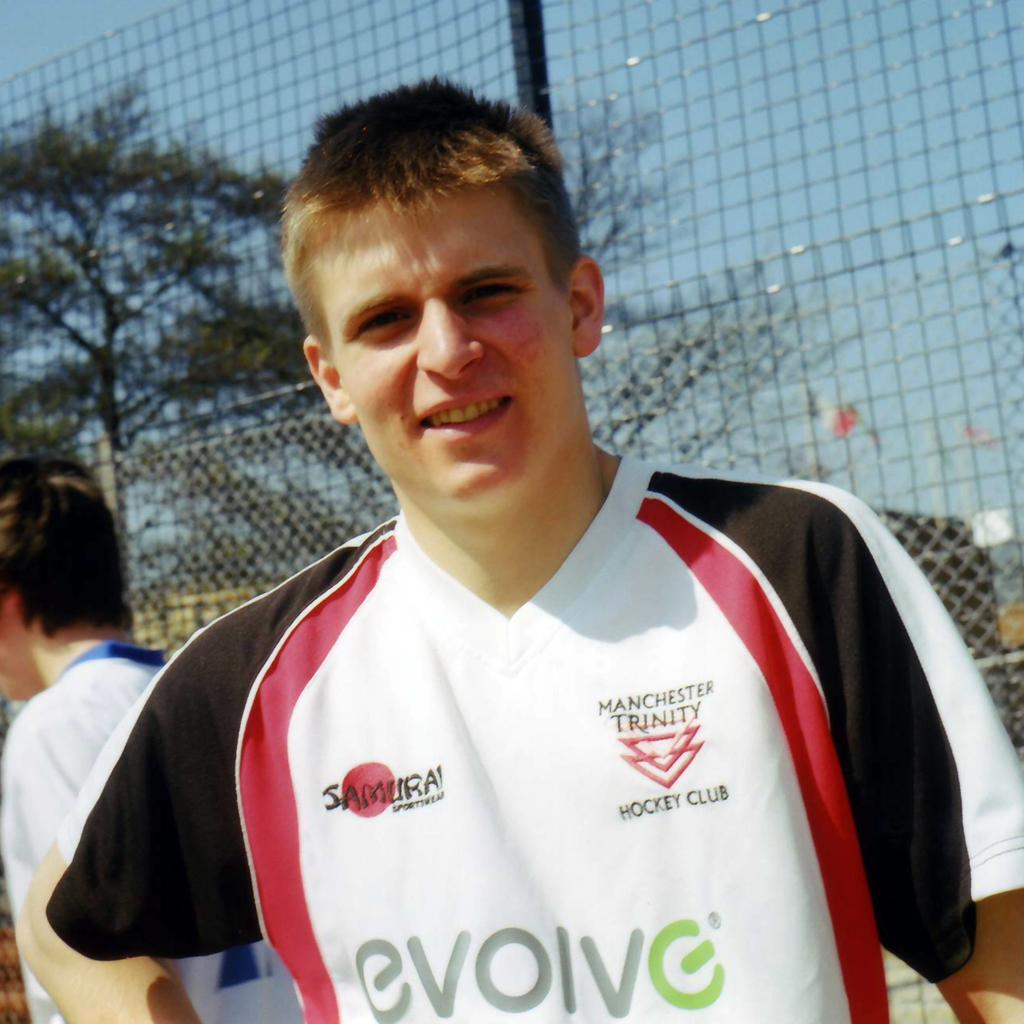<image>
Create a compact narrative representing the image presented. A man wearing a shirt that says evolve on the front. 